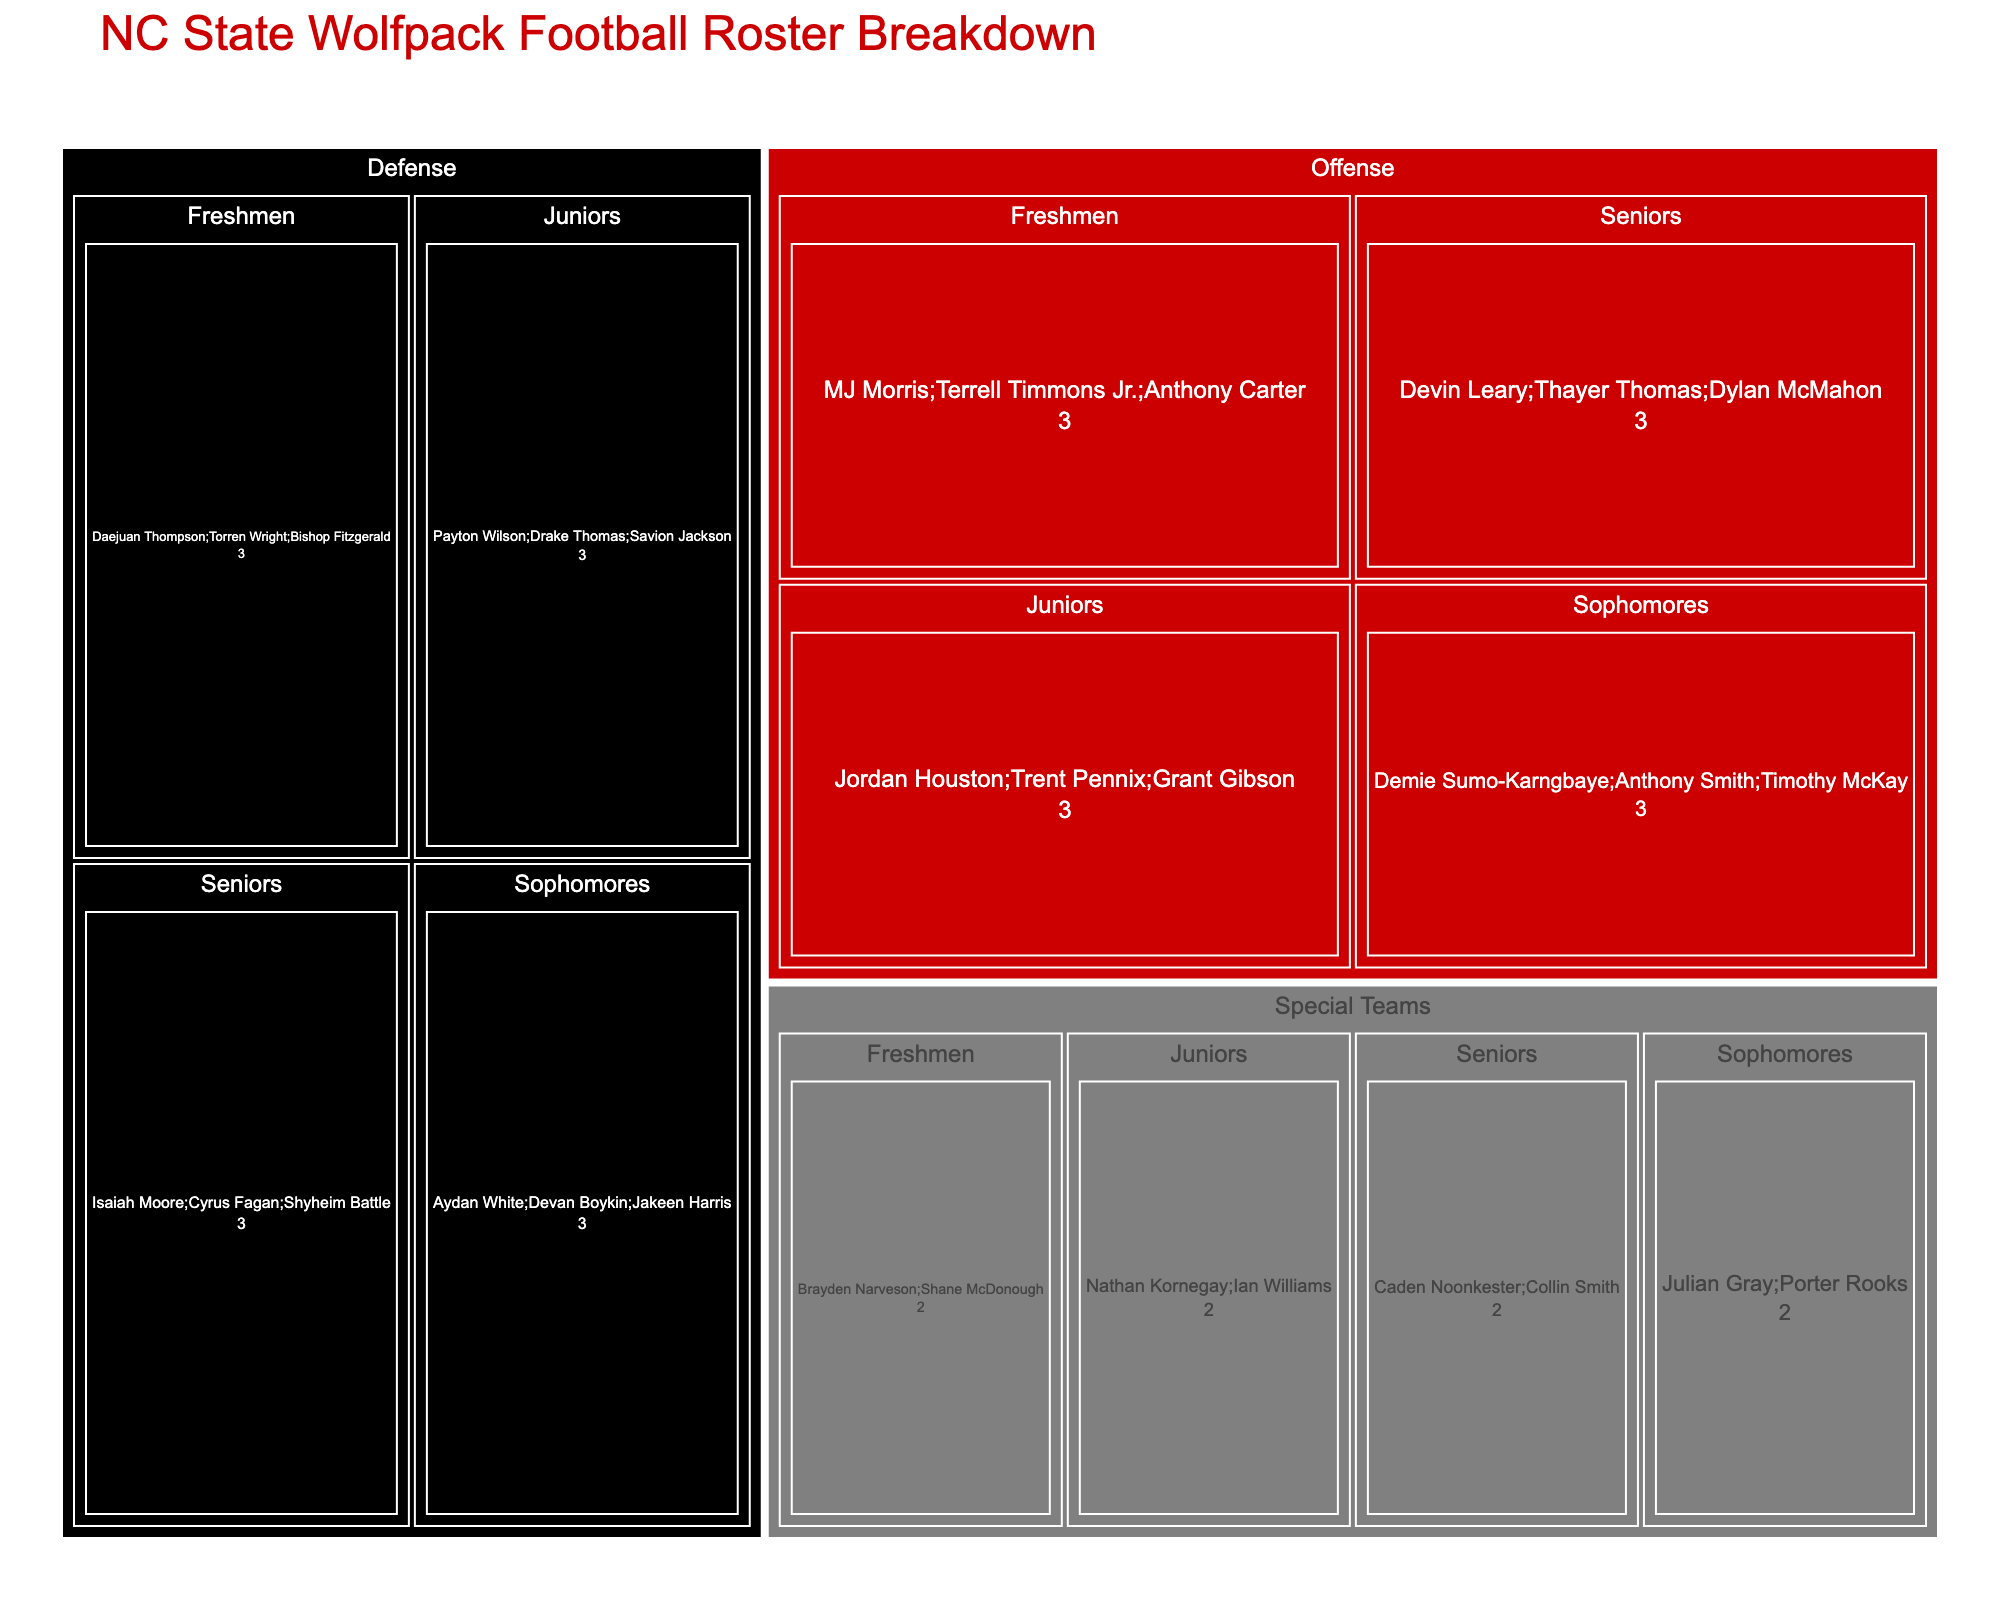how many total seniors are on the NC State Wolfpack football team? Add the number of seniors from the Offense, Defense, and Special Teams groups. Offense has 3 seniors, Defense has 3 seniors, and Special Teams has 2 seniors. Therefore, 3 + 3 + 2 = 8 seniors in total.
Answer: 8 Which position has the most experienced players? Compare the count of players in each position by their experience level. The figure shows that both Offense and Defense have 3 seniors, while Special Teams have 2 seniors. Since 3 > 2, the Offense and Defense both have the most experienced players.
Answer: Offense and Defense Which position group has the fewest freshmen players? Compare the number of freshmen players across Offense, Defense, and Special Teams. The figure depicts 3 freshmen in both Offense and Defense, but only 2 freshmen in Special Teams. Since 2 < 3, Special Teams have the fewest freshmen players.
Answer: Special Teams What is the total number of players in the Offense position group? Add the number of players from all experience levels in the Offense group. There are 3 seniors, 3 juniors, 3 sophomores, and 3 freshmen. 3 + 3 + 3 + 3 = 12 players in the Offense group.
Answer: 12 Is there an equal distribution of players across all experience levels in the Defense position group? Check the number of players at each experience level in the Defense group. The figure shows that there are 3 seniors, 3 juniors, 3 sophomores, and 3 freshmen, indicating an equal distribution of players.
Answer: Yes Which experience group has more players: Juniors or Freshmen? Add the number of juniors and freshmen across Offense, Defense, and Special Teams. Juniors: 3 (Offense) + 3 (Defense) + 2 (Special Teams) = 8. Freshmen: 3 (Offense) + 3 (Defense) + 2 (Special Teams) = 8. Both groups have an equal number of players.
Answer: Equal Within the Defense position, which experience group is larger: Seniors or Juniors? Compare the number of seniors and juniors in the Defense position. Both seniors and juniors in Defense have the same number, which is 3.
Answer: Equal How does the number of players in Special Teams compare to those in Offense? Add the number of players in each experience level within Special Teams and Offense. Special Teams have 2 (seniors) + 2 (juniors) + 2 (sophomores) + 2 (freshmen) = 8. Offense has 3 (seniors) + 3 (juniors) + 3 (sophomores) + 3 (freshmen) = 12. Since 8 < 12, Special Teams have fewer players than Offense.
Answer: Offense has more What's the total number of players in the junior experience level across all positions? Sum the number of juniors from all positions: Offense (3), Defense (3), and Special Teams (2). The total is 3 + 3 + 2 = 8 players.
Answer: 8 Which position group is equally represented in each experience level? Check each position group for equal representation across all experience levels. The figure shows that Offense and Defense both have 3 players in each level, ensuring equal representation. Special Teams have 2 players per experience level.
Answer: Offense and Defense 